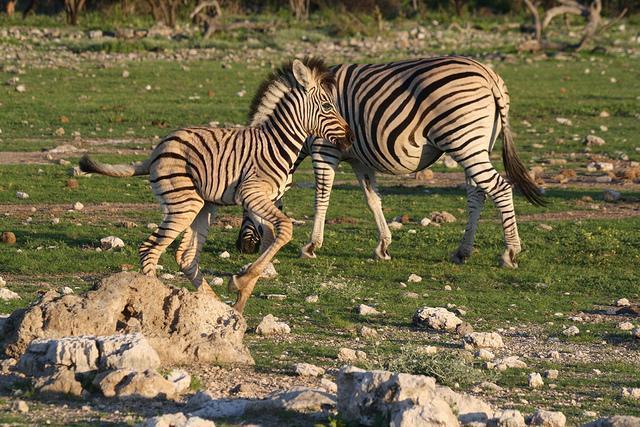How many animals are there?
Give a very brief answer. 2. How many zebras are in the picture?
Give a very brief answer. 2. How many zebras are there?
Give a very brief answer. 2. 